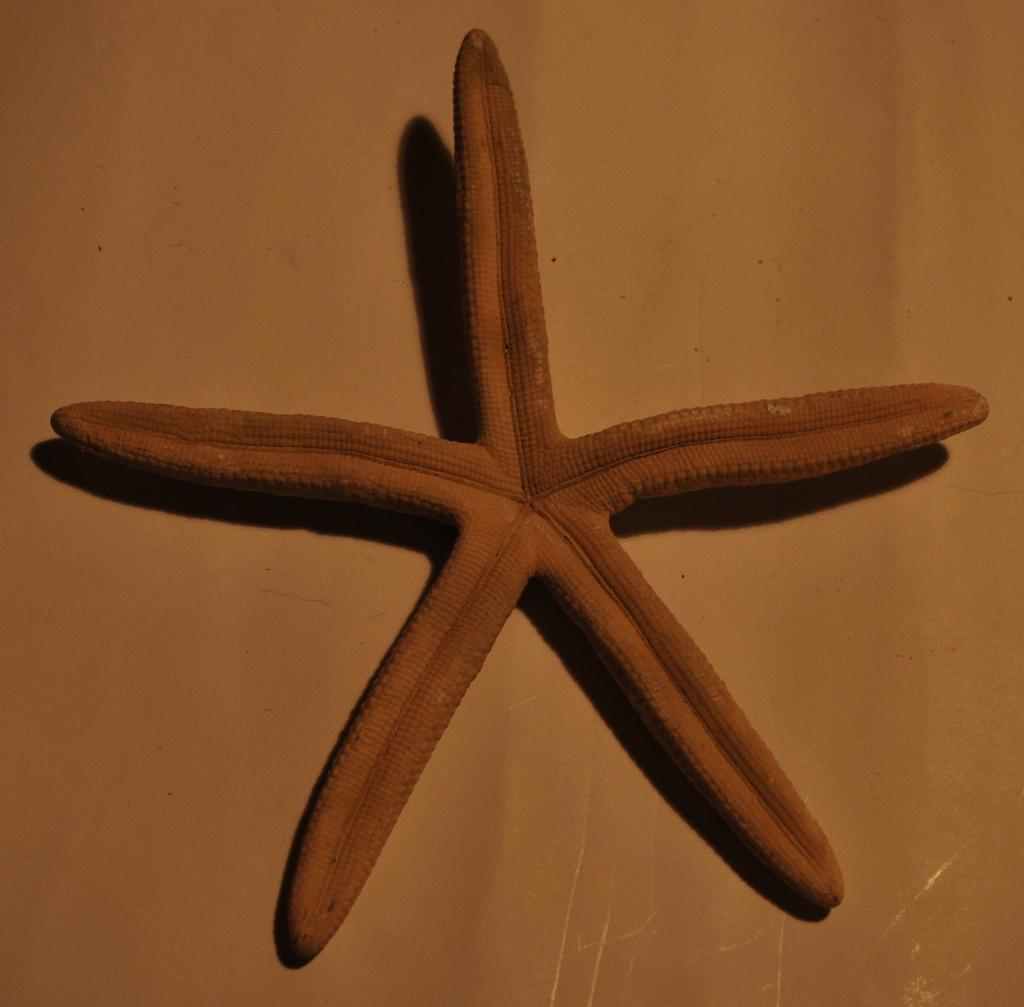What type of sea creature is in the image? There is a starfish in the image. What is the price of the train ticket for the cow in the image? There is no train, cow, or ticket present in the image; it features a starfish. 